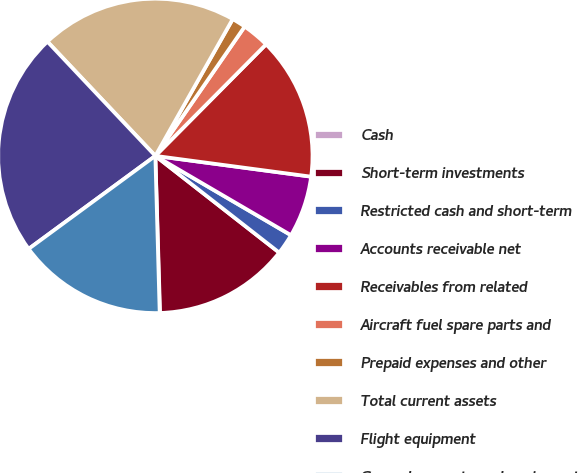Convert chart. <chart><loc_0><loc_0><loc_500><loc_500><pie_chart><fcel>Cash<fcel>Short-term investments<fcel>Restricted cash and short-term<fcel>Accounts receivable net<fcel>Receivables from related<fcel>Aircraft fuel spare parts and<fcel>Prepaid expenses and other<fcel>Total current assets<fcel>Flight equipment<fcel>Ground property and equipment<nl><fcel>0.04%<fcel>13.97%<fcel>2.13%<fcel>6.31%<fcel>14.67%<fcel>2.82%<fcel>1.43%<fcel>20.24%<fcel>23.03%<fcel>15.36%<nl></chart> 